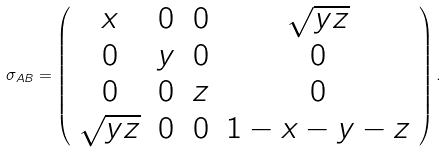Convert formula to latex. <formula><loc_0><loc_0><loc_500><loc_500>\sigma _ { A B } = \left ( \begin{array} [ c ] { c c c c } x & 0 & 0 & \sqrt { y z } \\ 0 & y & 0 & 0 \\ 0 & 0 & z & 0 \\ \sqrt { y z } & 0 & 0 & 1 - x - y - z \end{array} \right ) .</formula> 